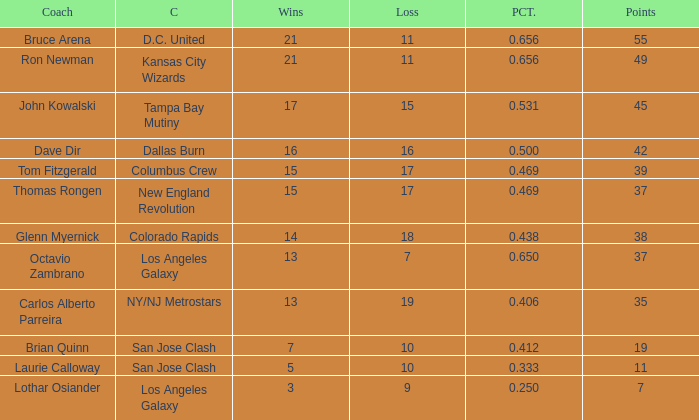What is the sum of points when Bruce Arena has 21 wins? 55.0. Could you parse the entire table? {'header': ['Coach', 'C', 'Wins', 'Loss', 'PCT.', 'Points'], 'rows': [['Bruce Arena', 'D.C. United', '21', '11', '0.656', '55'], ['Ron Newman', 'Kansas City Wizards', '21', '11', '0.656', '49'], ['John Kowalski', 'Tampa Bay Mutiny', '17', '15', '0.531', '45'], ['Dave Dir', 'Dallas Burn', '16', '16', '0.500', '42'], ['Tom Fitzgerald', 'Columbus Crew', '15', '17', '0.469', '39'], ['Thomas Rongen', 'New England Revolution', '15', '17', '0.469', '37'], ['Glenn Myernick', 'Colorado Rapids', '14', '18', '0.438', '38'], ['Octavio Zambrano', 'Los Angeles Galaxy', '13', '7', '0.650', '37'], ['Carlos Alberto Parreira', 'NY/NJ Metrostars', '13', '19', '0.406', '35'], ['Brian Quinn', 'San Jose Clash', '7', '10', '0.412', '19'], ['Laurie Calloway', 'San Jose Clash', '5', '10', '0.333', '11'], ['Lothar Osiander', 'Los Angeles Galaxy', '3', '9', '0.250', '7']]} 